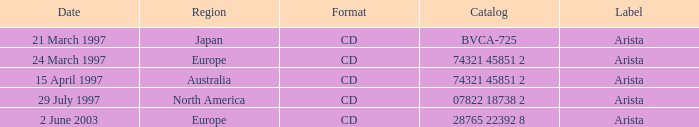What's the Date with the Region of Europe and has a Catalog of 28765 22392 8? 2 June 2003. 